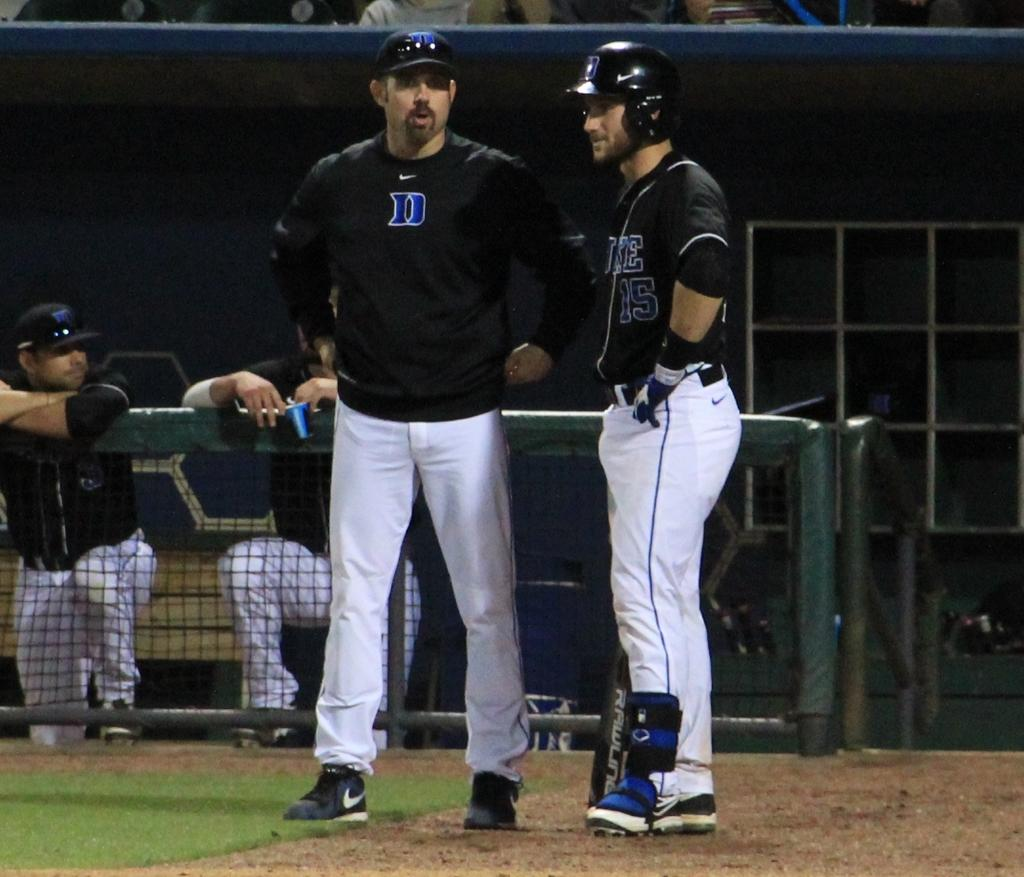<image>
Give a short and clear explanation of the subsequent image. Player number 15 talks to a coach near the dugout at a baseball game. 